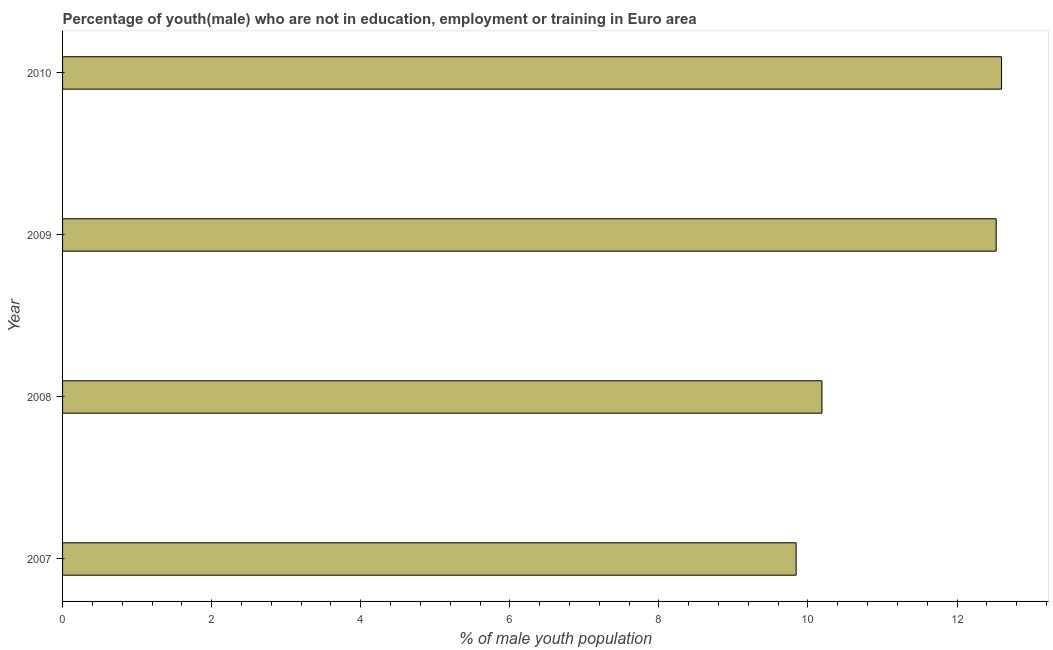Does the graph contain grids?
Keep it short and to the point. No. What is the title of the graph?
Provide a short and direct response. Percentage of youth(male) who are not in education, employment or training in Euro area. What is the label or title of the X-axis?
Your answer should be very brief. % of male youth population. What is the label or title of the Y-axis?
Provide a succinct answer. Year. What is the unemployed male youth population in 2009?
Provide a short and direct response. 12.52. Across all years, what is the maximum unemployed male youth population?
Provide a succinct answer. 12.6. Across all years, what is the minimum unemployed male youth population?
Your answer should be very brief. 9.84. In which year was the unemployed male youth population maximum?
Provide a short and direct response. 2010. In which year was the unemployed male youth population minimum?
Provide a short and direct response. 2007. What is the sum of the unemployed male youth population?
Your answer should be compact. 45.15. What is the difference between the unemployed male youth population in 2009 and 2010?
Provide a succinct answer. -0.07. What is the average unemployed male youth population per year?
Make the answer very short. 11.29. What is the median unemployed male youth population?
Give a very brief answer. 11.36. Do a majority of the years between 2008 and 2010 (inclusive) have unemployed male youth population greater than 7.2 %?
Offer a terse response. Yes. What is the ratio of the unemployed male youth population in 2007 to that in 2009?
Provide a short and direct response. 0.79. Is the unemployed male youth population in 2007 less than that in 2010?
Offer a terse response. Yes. What is the difference between the highest and the second highest unemployed male youth population?
Your answer should be very brief. 0.07. What is the difference between the highest and the lowest unemployed male youth population?
Provide a short and direct response. 2.76. How many years are there in the graph?
Ensure brevity in your answer.  4. What is the % of male youth population in 2007?
Your answer should be very brief. 9.84. What is the % of male youth population in 2008?
Give a very brief answer. 10.19. What is the % of male youth population of 2009?
Make the answer very short. 12.52. What is the % of male youth population of 2010?
Your answer should be compact. 12.6. What is the difference between the % of male youth population in 2007 and 2008?
Make the answer very short. -0.35. What is the difference between the % of male youth population in 2007 and 2009?
Provide a succinct answer. -2.68. What is the difference between the % of male youth population in 2007 and 2010?
Your response must be concise. -2.76. What is the difference between the % of male youth population in 2008 and 2009?
Give a very brief answer. -2.34. What is the difference between the % of male youth population in 2008 and 2010?
Provide a succinct answer. -2.41. What is the difference between the % of male youth population in 2009 and 2010?
Ensure brevity in your answer.  -0.07. What is the ratio of the % of male youth population in 2007 to that in 2008?
Offer a very short reply. 0.97. What is the ratio of the % of male youth population in 2007 to that in 2009?
Offer a very short reply. 0.79. What is the ratio of the % of male youth population in 2007 to that in 2010?
Ensure brevity in your answer.  0.78. What is the ratio of the % of male youth population in 2008 to that in 2009?
Your answer should be very brief. 0.81. What is the ratio of the % of male youth population in 2008 to that in 2010?
Your response must be concise. 0.81. 